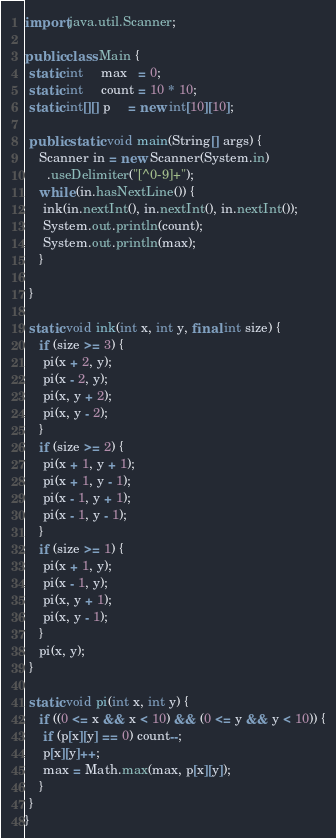<code> <loc_0><loc_0><loc_500><loc_500><_Java_>import java.util.Scanner;

public class Main {
 static int     max   = 0;
 static int     count = 10 * 10;
 static int[][] p     = new int[10][10];

 public static void main(String[] args) {
	Scanner in = new Scanner(System.in)
	  .useDelimiter("[^0-9]+");
	while (in.hasNextLine()) {
	 ink(in.nextInt(), in.nextInt(), in.nextInt());
	 System.out.println(count);
	 System.out.println(max);
	}

 }

 static void ink(int x, int y, final int size) {
	if (size >= 3) {
	 pi(x + 2, y);
	 pi(x - 2, y);
	 pi(x, y + 2);
	 pi(x, y - 2);
	}
	if (size >= 2) {
	 pi(x + 1, y + 1);
	 pi(x + 1, y - 1);
	 pi(x - 1, y + 1);
	 pi(x - 1, y - 1);
	}
	if (size >= 1) {
	 pi(x + 1, y);
	 pi(x - 1, y);
	 pi(x, y + 1);
	 pi(x, y - 1);
	}
	pi(x, y);
 }

 static void pi(int x, int y) {
	if ((0 <= x && x < 10) && (0 <= y && y < 10)) {
	 if (p[x][y] == 0) count--;
	 p[x][y]++;
	 max = Math.max(max, p[x][y]);
	}
 }
}</code> 